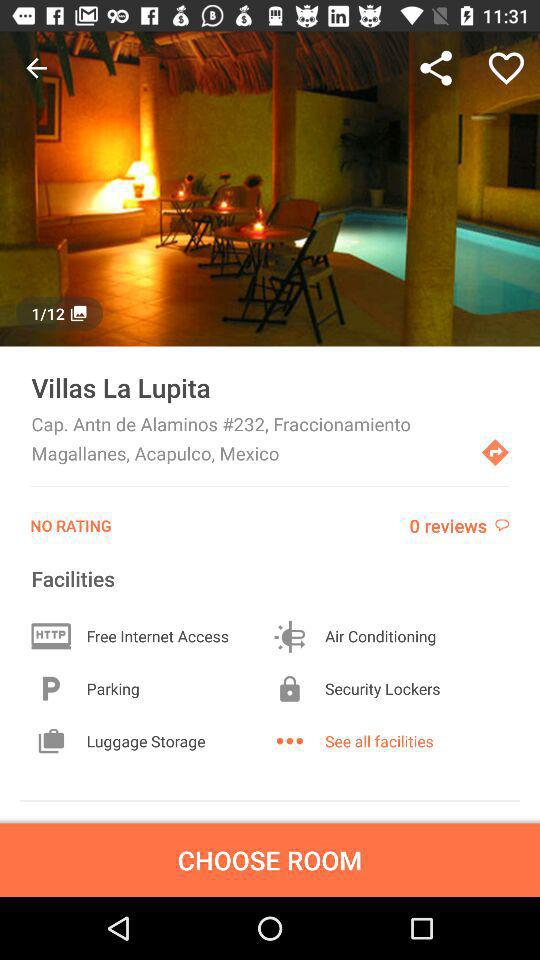How many reviews has the property received?
Answer the question using a single word or phrase. 0 